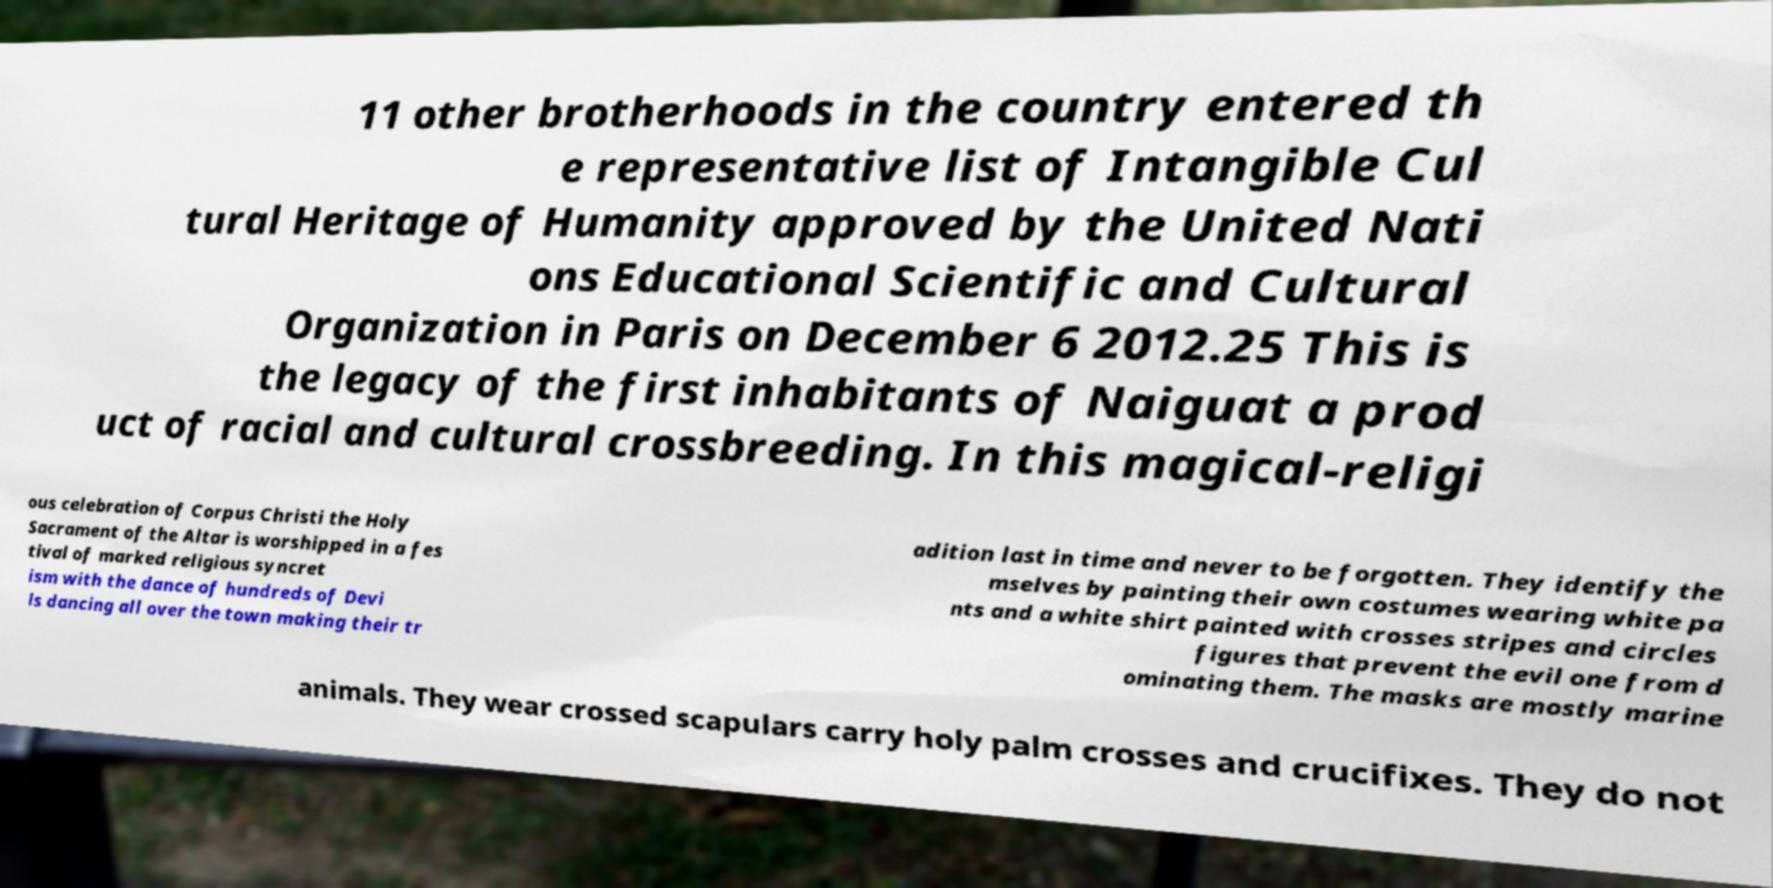There's text embedded in this image that I need extracted. Can you transcribe it verbatim? 11 other brotherhoods in the country entered th e representative list of Intangible Cul tural Heritage of Humanity approved by the United Nati ons Educational Scientific and Cultural Organization in Paris on December 6 2012.25 This is the legacy of the first inhabitants of Naiguat a prod uct of racial and cultural crossbreeding. In this magical-religi ous celebration of Corpus Christi the Holy Sacrament of the Altar is worshipped in a fes tival of marked religious syncret ism with the dance of hundreds of Devi ls dancing all over the town making their tr adition last in time and never to be forgotten. They identify the mselves by painting their own costumes wearing white pa nts and a white shirt painted with crosses stripes and circles figures that prevent the evil one from d ominating them. The masks are mostly marine animals. They wear crossed scapulars carry holy palm crosses and crucifixes. They do not 